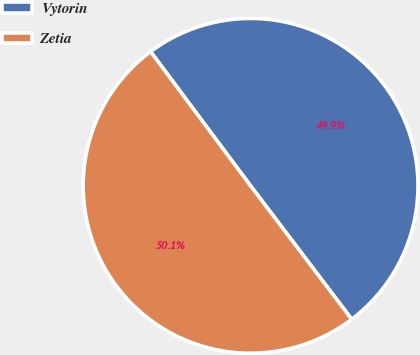<chart> <loc_0><loc_0><loc_500><loc_500><pie_chart><fcel>Vytorin<fcel>Zetia<nl><fcel>49.87%<fcel>50.13%<nl></chart> 